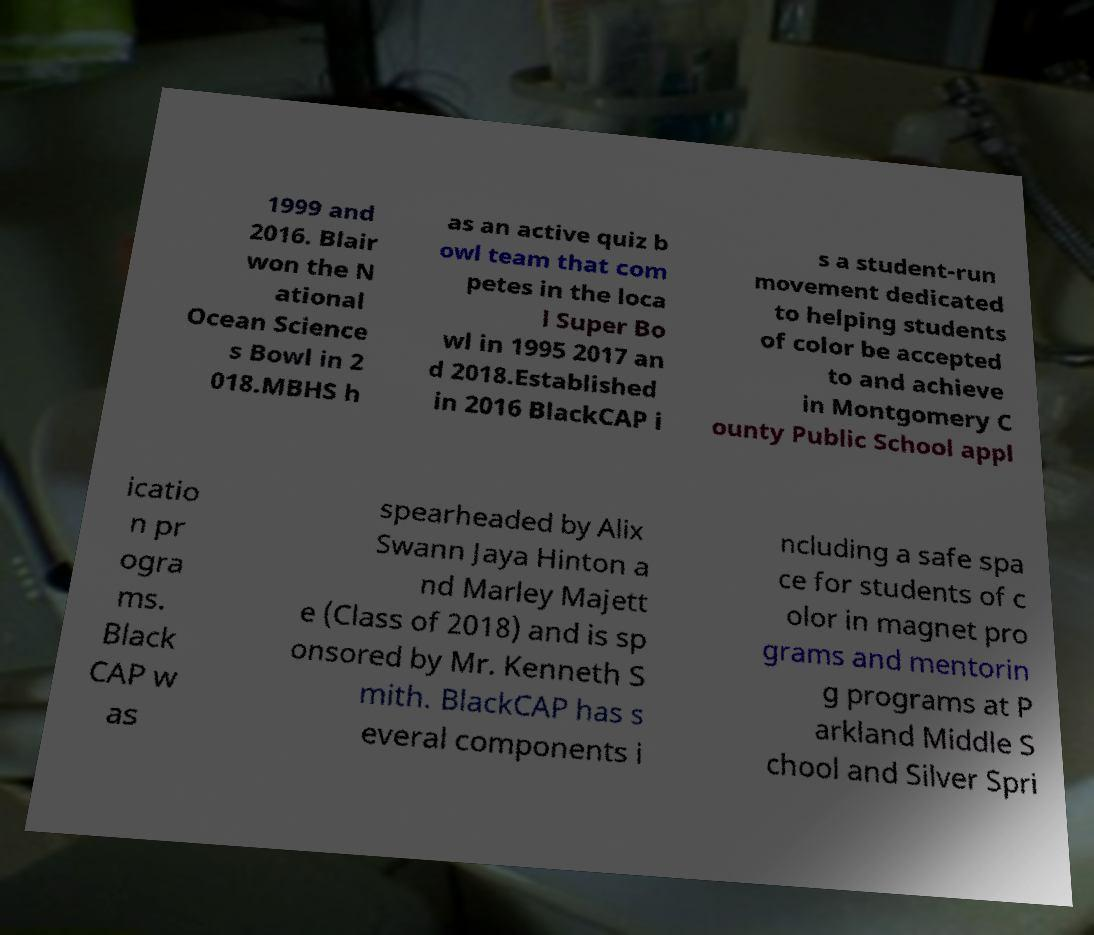What messages or text are displayed in this image? I need them in a readable, typed format. 1999 and 2016. Blair won the N ational Ocean Science s Bowl in 2 018.MBHS h as an active quiz b owl team that com petes in the loca l Super Bo wl in 1995 2017 an d 2018.Established in 2016 BlackCAP i s a student-run movement dedicated to helping students of color be accepted to and achieve in Montgomery C ounty Public School appl icatio n pr ogra ms. Black CAP w as spearheaded by Alix Swann Jaya Hinton a nd Marley Majett e (Class of 2018) and is sp onsored by Mr. Kenneth S mith. BlackCAP has s everal components i ncluding a safe spa ce for students of c olor in magnet pro grams and mentorin g programs at P arkland Middle S chool and Silver Spri 